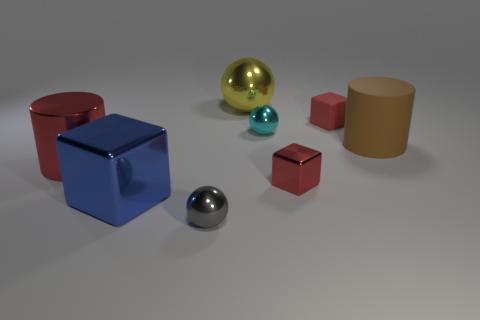Can you describe the spatial arrangement of the objects in the image? Certainly! In the image, you can see a collection of geometric shapes arranged on a flat surface. To the left is a large red cube, followed by a smaller red cube of a similar shade. In the center, there's a large yellow sphere with a shiny surface. To the right of the sphere are three objects: a large blue cube, a smaller blue sphere, and a tiny red cube. In the far right, there is a large matte brown cylinder. The objects are positioned in a somewhat staggered manner, giving the impression of depth. 